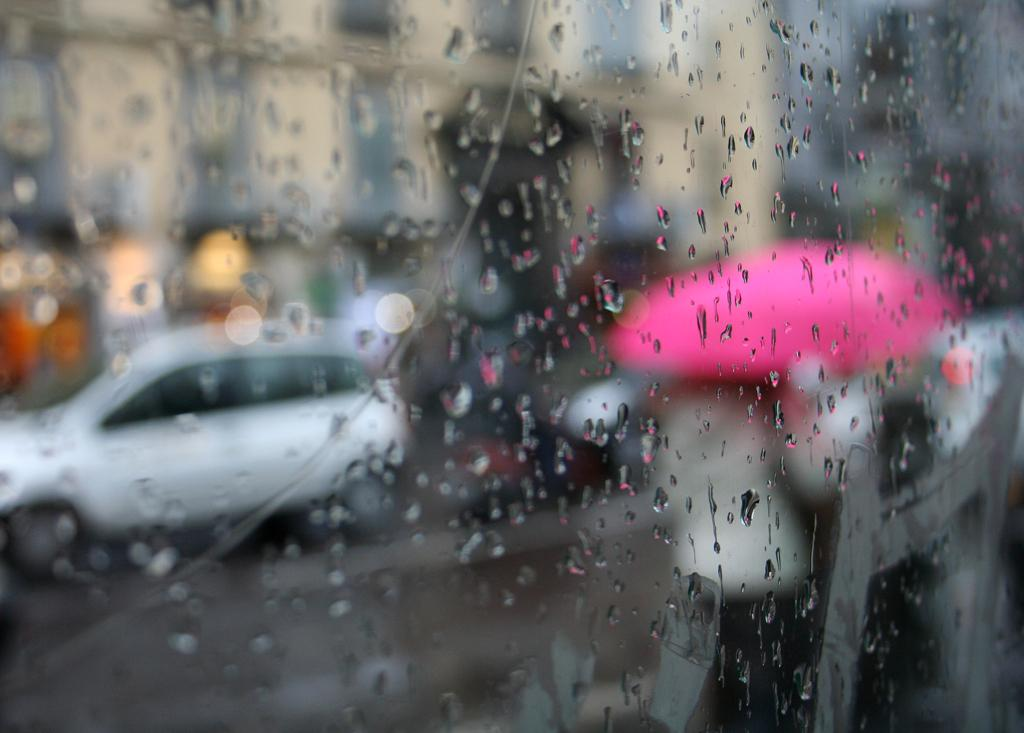What object in the image has water droplets on it? There is a glass with water droplets on it in the image. What can be seen in the background of the image? There is a car and a person holding a pink color umbrella in the background of the image. What type of chickens are present in the image? There are no chickens present in the image. What religious symbols can be seen in the image? There are no religious symbols present in the image. 